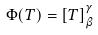Convert formula to latex. <formula><loc_0><loc_0><loc_500><loc_500>\Phi ( T ) = [ T ] _ { \beta } ^ { \gamma }</formula> 